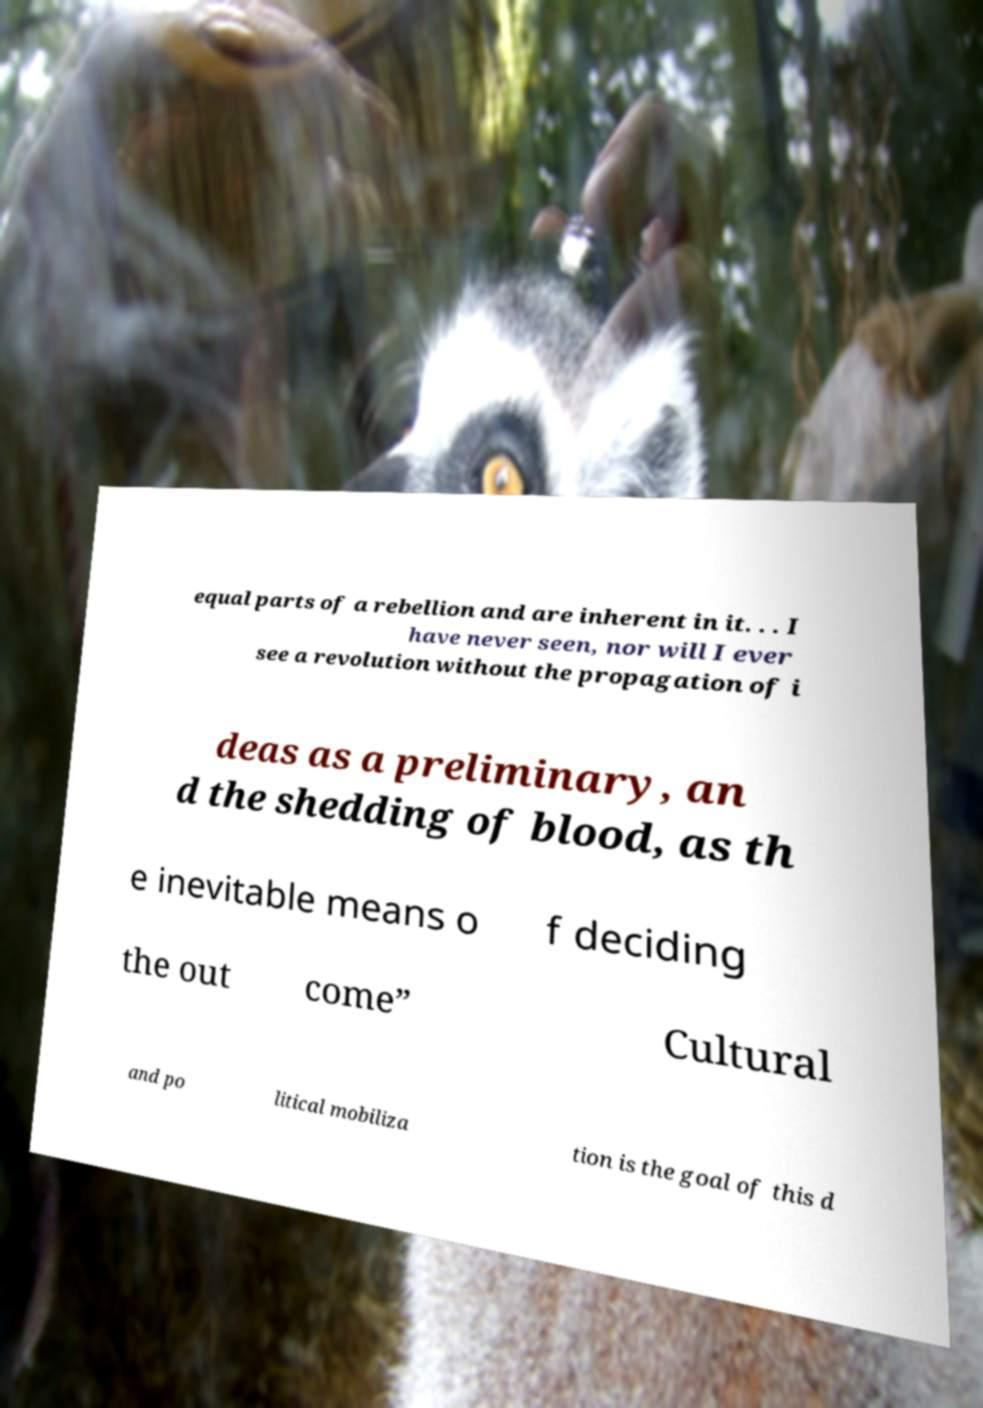For documentation purposes, I need the text within this image transcribed. Could you provide that? equal parts of a rebellion and are inherent in it. . . I have never seen, nor will I ever see a revolution without the propagation of i deas as a preliminary, an d the shedding of blood, as th e inevitable means o f deciding the out come” Cultural and po litical mobiliza tion is the goal of this d 